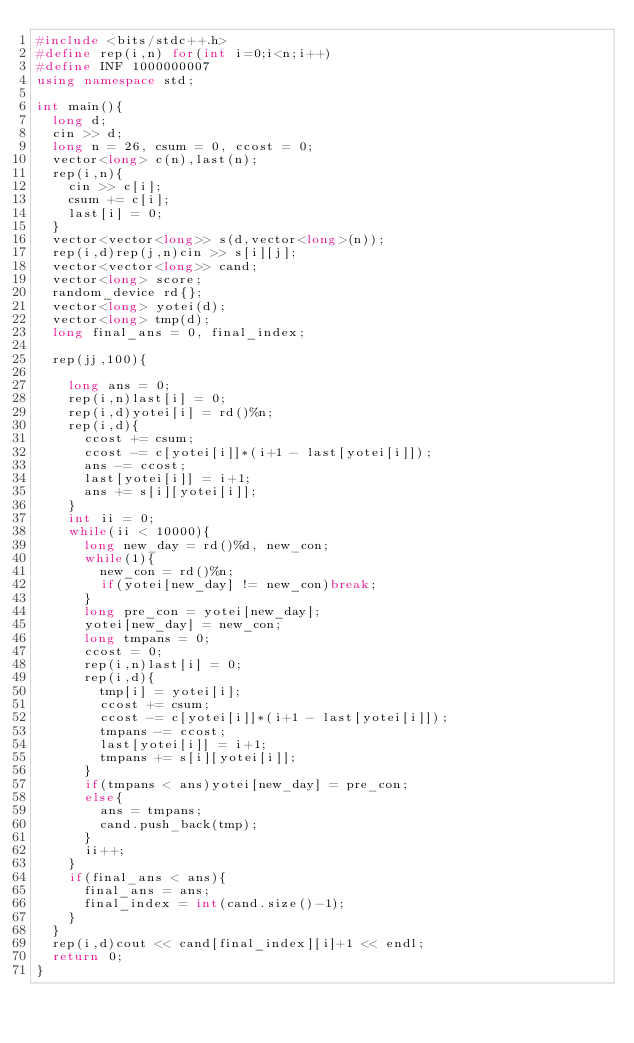<code> <loc_0><loc_0><loc_500><loc_500><_C++_>#include <bits/stdc++.h>
#define rep(i,n) for(int i=0;i<n;i++)
#define INF 1000000007
using namespace std;

int main(){
  long d;
  cin >> d;
  long n = 26, csum = 0, ccost = 0;
  vector<long> c(n),last(n);
  rep(i,n){
    cin >> c[i];
    csum += c[i];
    last[i] = 0;
  }
  vector<vector<long>> s(d,vector<long>(n));
  rep(i,d)rep(j,n)cin >> s[i][j];
  vector<vector<long>> cand;
  vector<long> score;
  random_device rd{};
  vector<long> yotei(d);
  vector<long> tmp(d);
  long final_ans = 0, final_index;

  rep(jj,100){

    long ans = 0;
    rep(i,n)last[i] = 0;
    rep(i,d)yotei[i] = rd()%n;
    rep(i,d){
      ccost += csum;
      ccost -= c[yotei[i]]*(i+1 - last[yotei[i]]);
      ans -= ccost;
      last[yotei[i]] = i+1;
      ans += s[i][yotei[i]];
    }
    int ii = 0;
    while(ii < 10000){
      long new_day = rd()%d, new_con;
      while(1){
        new_con = rd()%n;
        if(yotei[new_day] != new_con)break;
      }
      long pre_con = yotei[new_day];
      yotei[new_day] = new_con;
      long tmpans = 0;
      ccost = 0;
      rep(i,n)last[i] = 0;
      rep(i,d){
        tmp[i] = yotei[i];
        ccost += csum;
        ccost -= c[yotei[i]]*(i+1 - last[yotei[i]]);
        tmpans -= ccost;
        last[yotei[i]] = i+1;
        tmpans += s[i][yotei[i]];
      }
      if(tmpans < ans)yotei[new_day] = pre_con;
      else{
        ans = tmpans;
        cand.push_back(tmp);
      }
      ii++;
    }
    if(final_ans < ans){
      final_ans = ans;
      final_index = int(cand.size()-1);
    }
  }
  rep(i,d)cout << cand[final_index][i]+1 << endl;
  return 0;
}</code> 